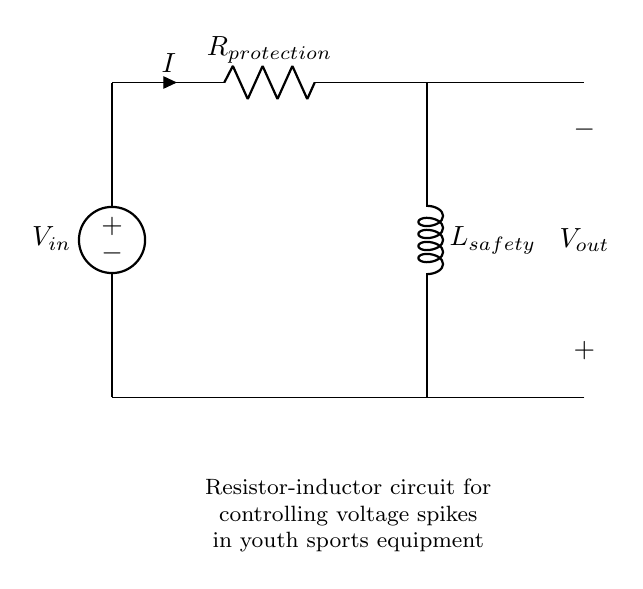What type of circuit is this? This circuit is a resistor-inductor circuit, indicated by the presence of a resistor and an inductor in the schematic. The symbols R for the resistor and L for the inductor confirm its type.
Answer: Resistor-Inductor What is the purpose of the resistor in this circuit? The resistor is used to limit the current flowing through the circuit, which helps to protect the circuit from overcurrent that could damage components.
Answer: Current limitation What do the symbols V_in and V_out represent? V_in represents the input voltage supplied to the circuit, while V_out represents the voltage across the load or output where the voltage is measured.
Answer: Input and output voltages What happens to the voltage spikes in this circuit? The inductor plays a critical role in preventing voltage spikes; when a sudden change in current occurs, the inductor resists this change, smoothing out the voltage.
Answer: Voltage smoothing How does the inductor respond to changes in current? The inductor opposes changes in current by generating a back electromotive force (EMF), which counteracts the increase or decrease in current flow.
Answer: Opposes current changes What is the expected relationship between V_in and V_out? The output voltage (V_out) is typically lower than the input voltage (V_in) due to the voltage drop across the resistor.
Answer: V_out < V_in 